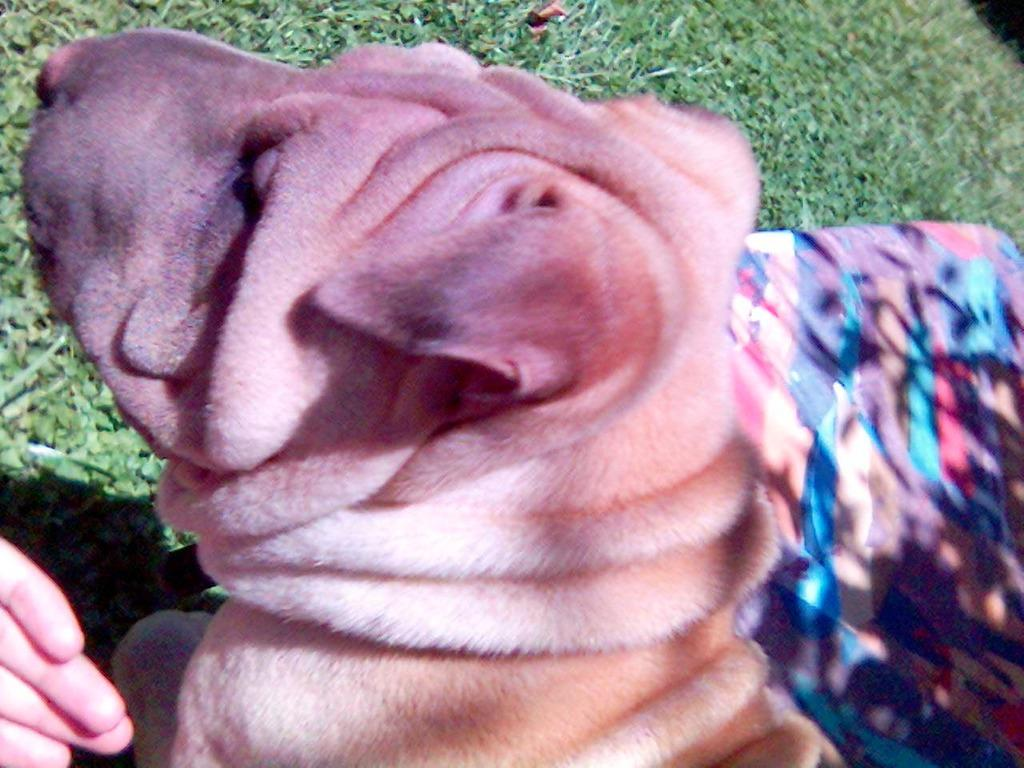What type of animal is present in the image? There is a dog in the image. Can you describe any other elements in the image? There is a hand of a person in the image. Are there any other animals present in the image? Yes, there is another dog in the image. What page of the book is the dog reading in the image? There is no book present in the image, so the dog cannot be reading any page. 